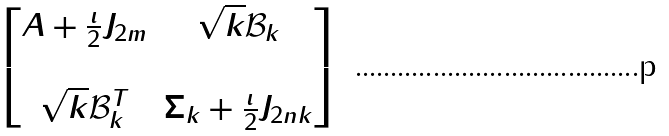<formula> <loc_0><loc_0><loc_500><loc_500>\begin{bmatrix} A + \frac { \imath } { 2 } J _ { 2 m } & \sqrt { k } \mathcal { B } _ { k } \\ & \\ \sqrt { k } \mathcal { B } _ { k } ^ { T } & \Sigma _ { k } + \frac { \imath } { 2 } J _ { 2 n k } \end{bmatrix}</formula> 